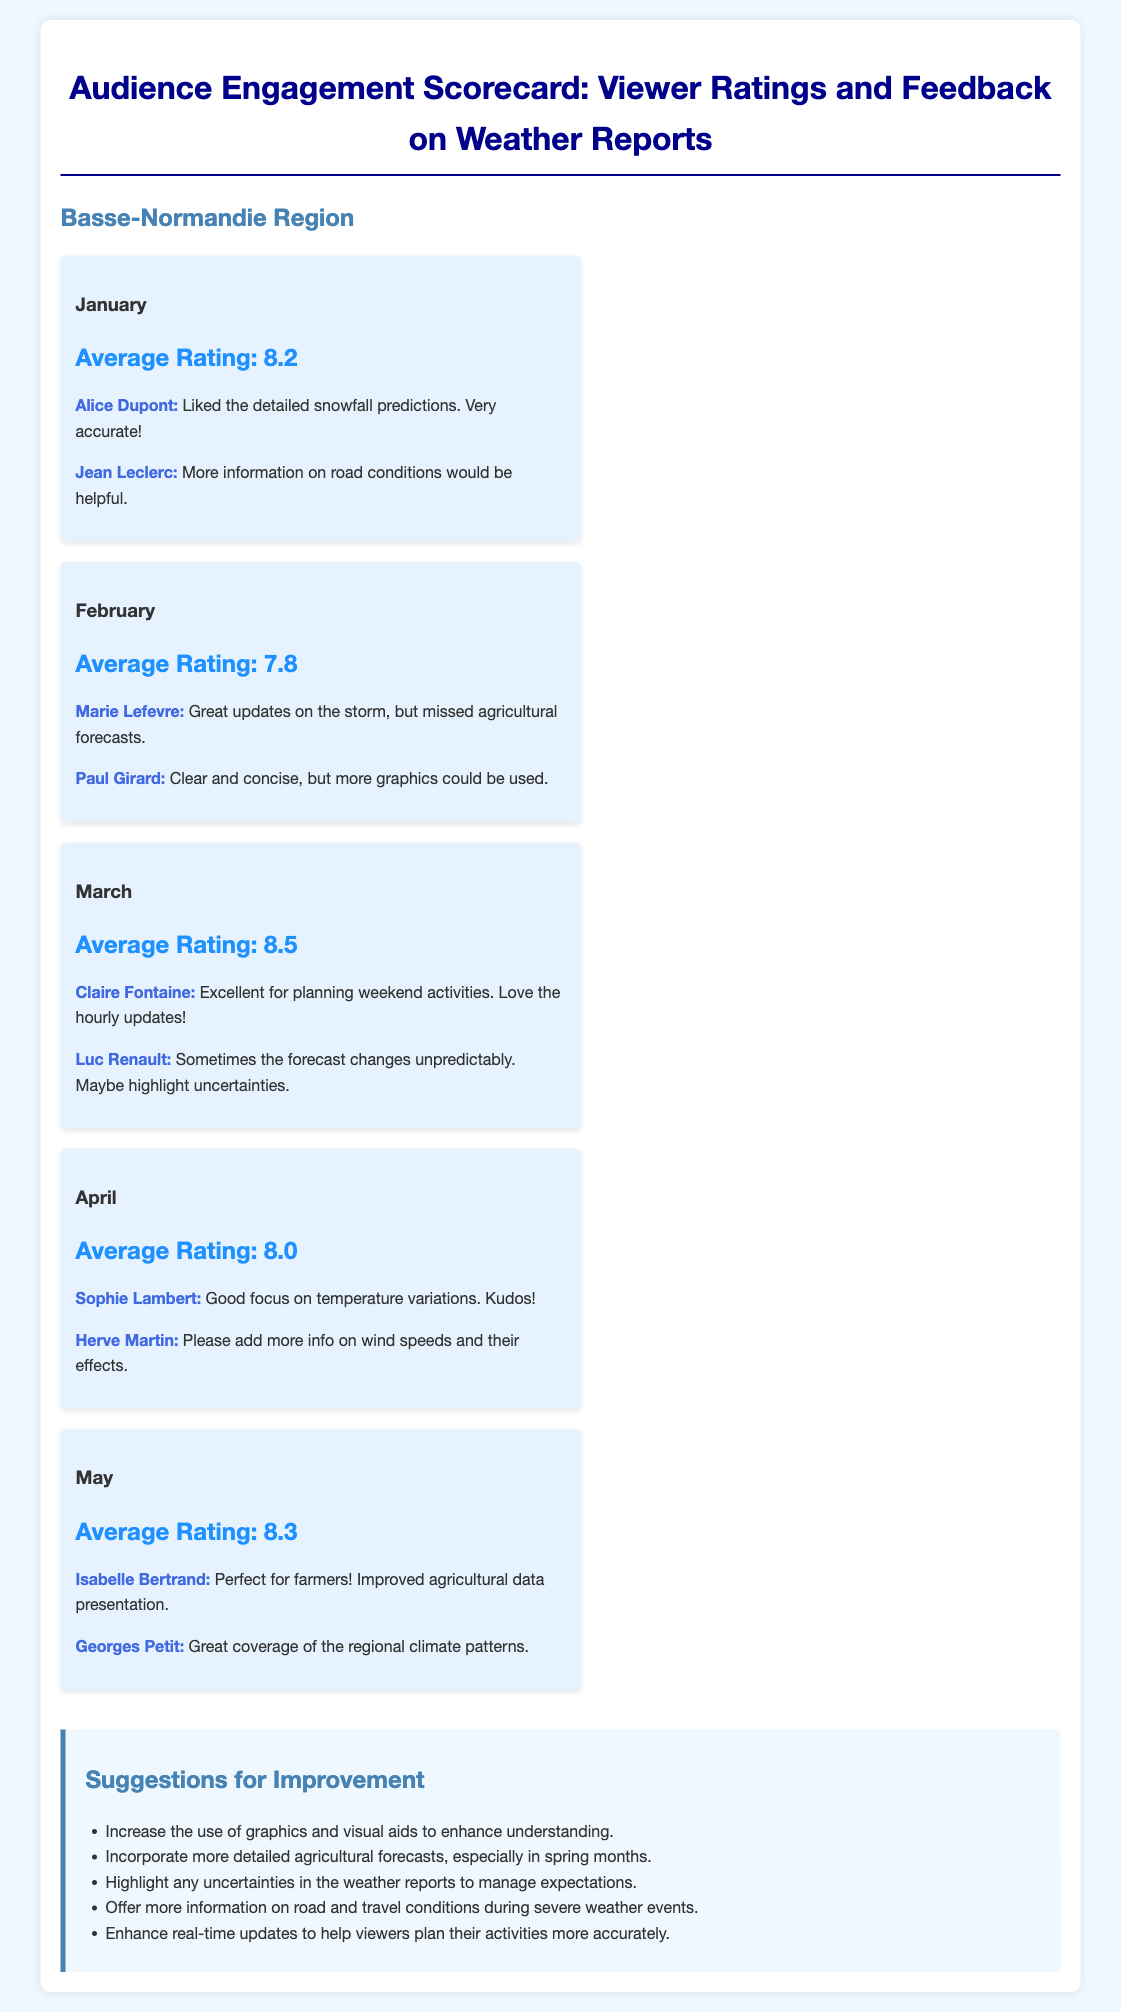What is the average rating for March? The average rating for March is explicitly stated in the document as 8.5.
Answer: 8.5 Who gave positive feedback on the detailed snowfall predictions? Alice Dupont is mentioned in January's feedback for liking the detailed snowfall predictions.
Answer: Alice Dupont What suggestion was made about agricultural forecasts? One suggestion emphasizes incorporating more detailed agricultural forecasts, particularly in spring months.
Answer: More detailed agricultural forecasts What was the average rating in February? The average rating for February is directly provided in the document as 7.8.
Answer: 7.8 Which month received the highest average rating? The document specifies that March has the highest average rating, which is 8.5.
Answer: March What feedback did Sophie Lambert give in April? Sophie Lambert's feedback in April praises the focus on temperature variations.
Answer: Good focus on temperature variations What common theme do the suggestions for improvement share? The suggestions generally focus on enhancing clarity and detail in weather reports.
Answer: Enhancing clarity and detail What feedback was given by Paul Girard in February? Paul Girard mentioned that the updates were clear and concise but suggested using more graphics.
Answer: Clear and concise, but more graphics could be used What overall sentiment is conveyed in the viewer feedback? The viewer feedback mostly conveys positive sentiments, highlighting improvements and suggestions.
Answer: Positive sentiments 